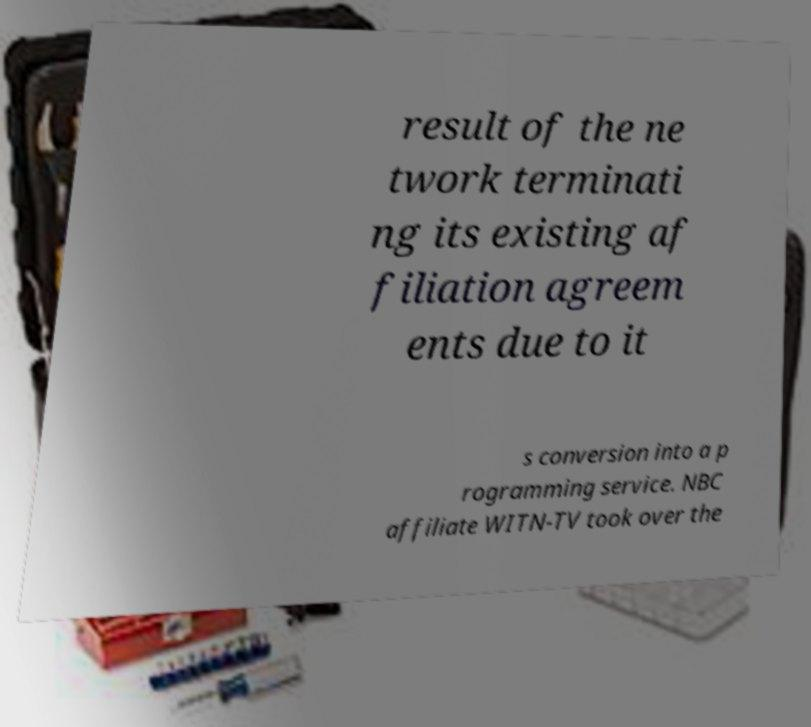Can you accurately transcribe the text from the provided image for me? result of the ne twork terminati ng its existing af filiation agreem ents due to it s conversion into a p rogramming service. NBC affiliate WITN-TV took over the 